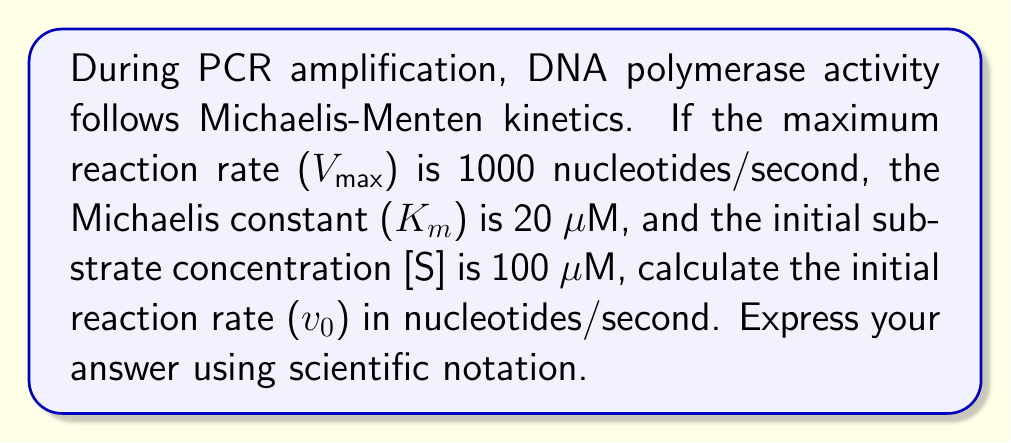Can you solve this math problem? To solve this problem, we'll use the Michaelis-Menten equation:

$$ v_0 = \frac{V_{max}[S]}{K_m + [S]} $$

Where:
- $v_0$ is the initial reaction rate
- $V_{max}$ is the maximum reaction rate
- $[S]$ is the initial substrate concentration
- $K_m$ is the Michaelis constant

Given:
- $V_{max} = 1000$ nucleotides/second
- $K_m = 20$ μM
- $[S] = 100$ μM

Step 1: Substitute the given values into the Michaelis-Menten equation:

$$ v_0 = \frac{1000 \times 100}{20 + 100} $$

Step 2: Simplify the numerator and denominator:

$$ v_0 = \frac{100,000}{120} $$

Step 3: Perform the division:

$$ v_0 = 833.33 \text{ nucleotides/second} $$

Step 4: Convert to scientific notation:

$$ v_0 = 8.33 \times 10^2 \text{ nucleotides/second} $$
Answer: $8.33 \times 10^2$ nucleotides/second 